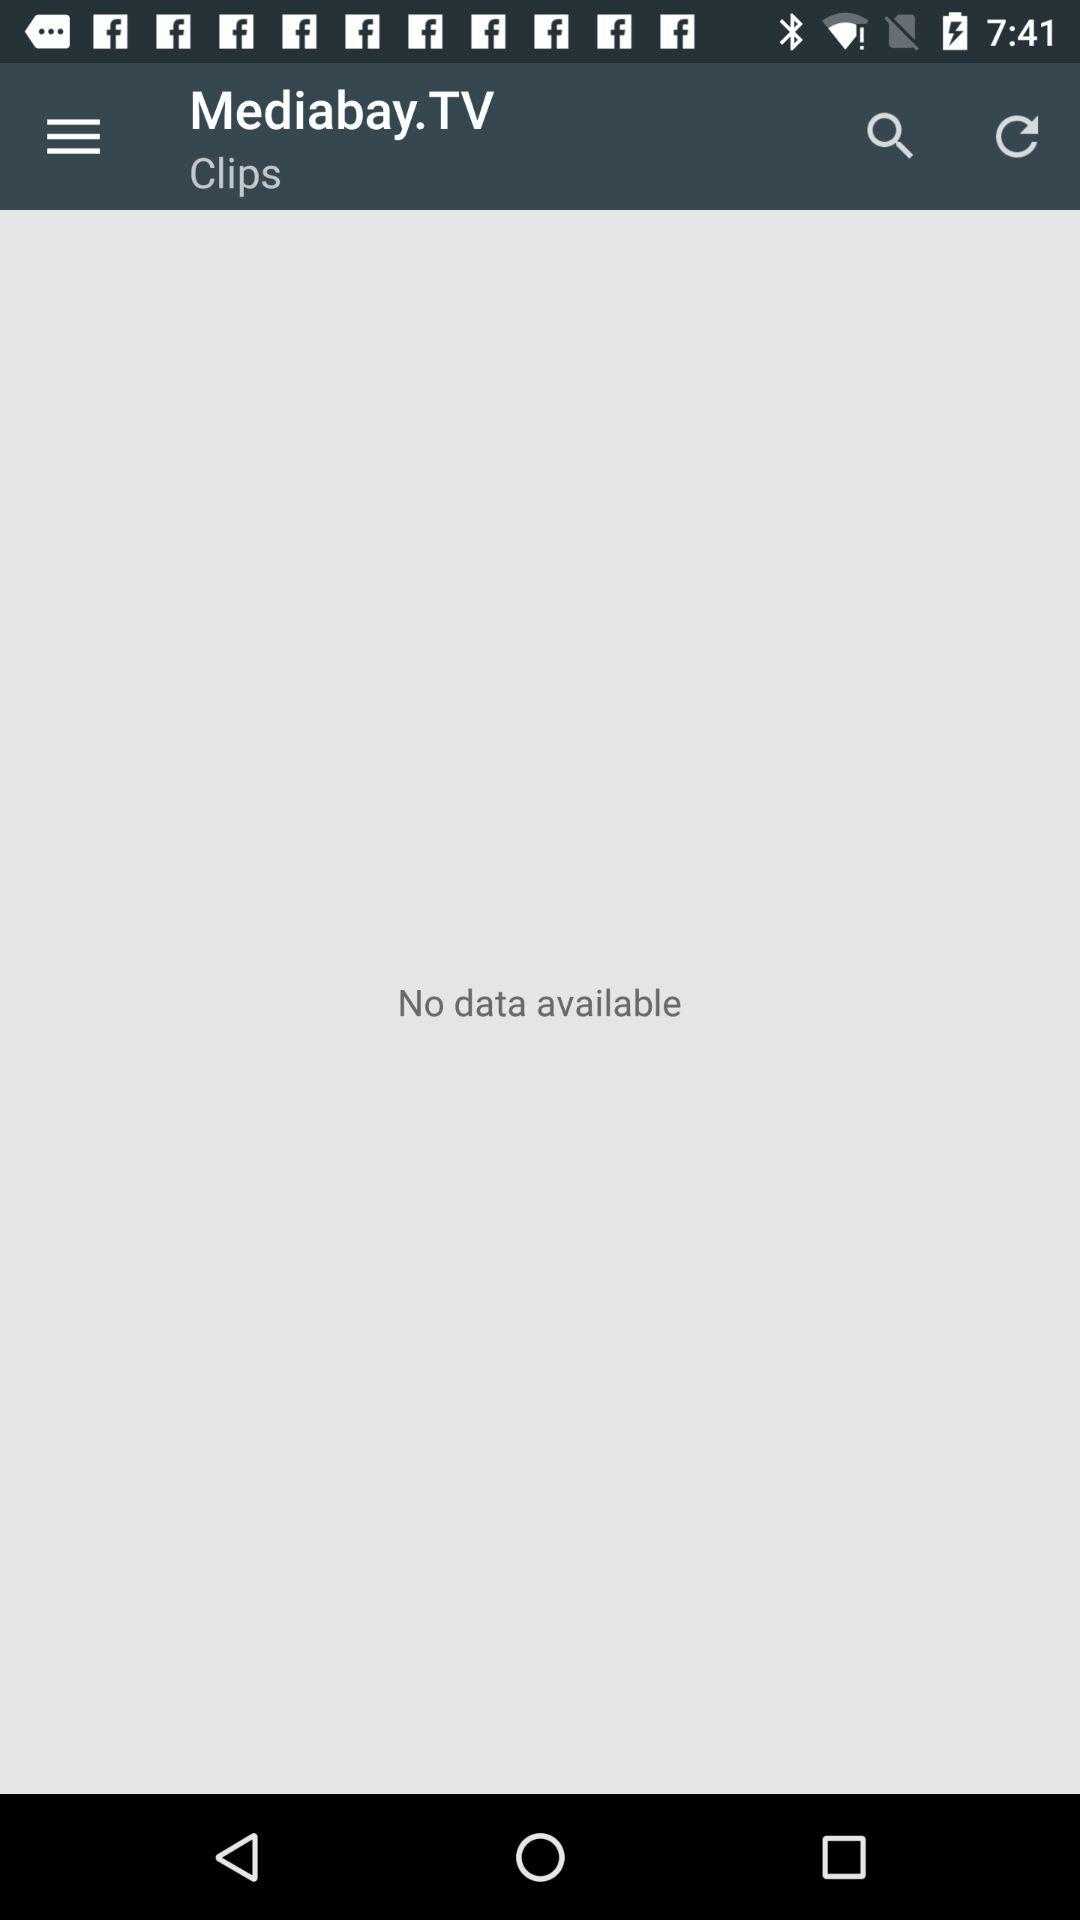What is the application name? The application name is "Mediabay.TV". 